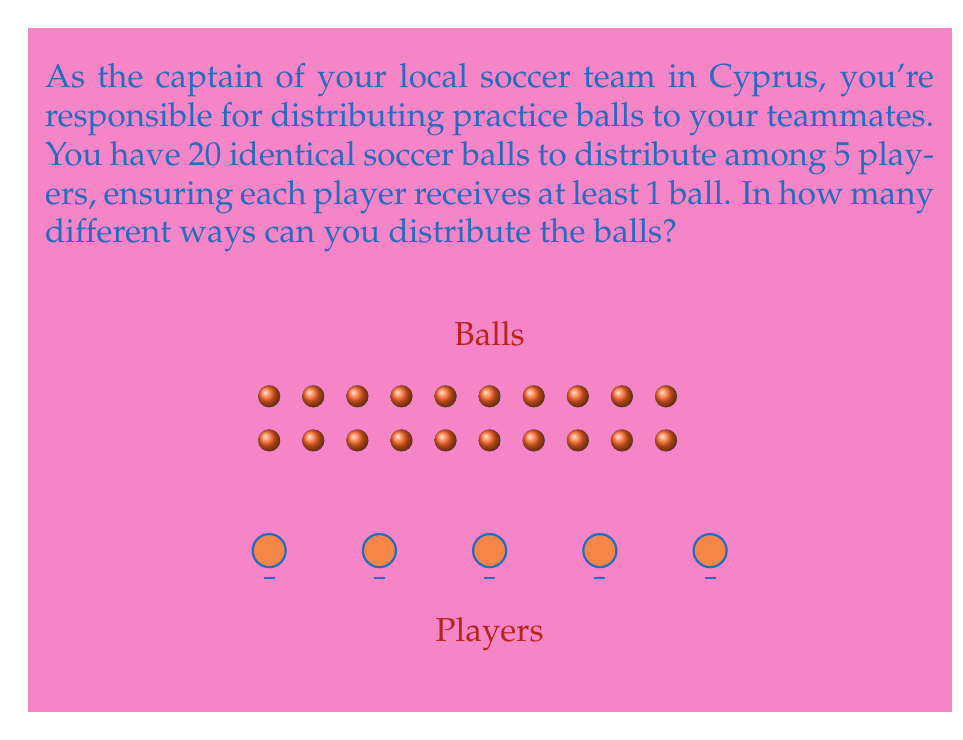Can you answer this question? Let's approach this step-by-step using the stars and bars method:

1) We need to distribute 20 balls among 5 players, with each player getting at least 1 ball.

2) To ensure each player gets at least 1 ball, we can first give each player 1 ball. This leaves us with 15 balls to distribute freely.

3) Now, we need to find the number of ways to distribute 15 identical objects (remaining balls) into 5 distinct groups (players).

4) This is equivalent to placing 4 dividers among 15 stars, which can be represented as:
   $$\underbrace{* * * * *}_\text{Player 1} | \underbrace{* * *}_\text{Player 2} | \underbrace{* * * *}_\text{Player 3} | \underbrace{*}_\text{Player 4} | \underbrace{* *}_\text{Player 5}$$

5) The total number of objects we're arranging is 15 stars + 4 dividers = 19 objects.

6) We need to choose positions for the 4 dividers out of these 19 positions.

7) This is a combination problem, represented as $\binom{19}{4}$ or $C(19,4)$.

8) We can calculate this using the formula:

   $$\binom{19}{4} = \frac{19!}{4!(19-4)!} = \frac{19!}{4!15!}$$

9) Calculating this:
   $$\frac{19 * 18 * 17 * 16}{4 * 3 * 2 * 1} = 3876$$

Therefore, there are 3876 different ways to distribute the balls.
Answer: 3876 